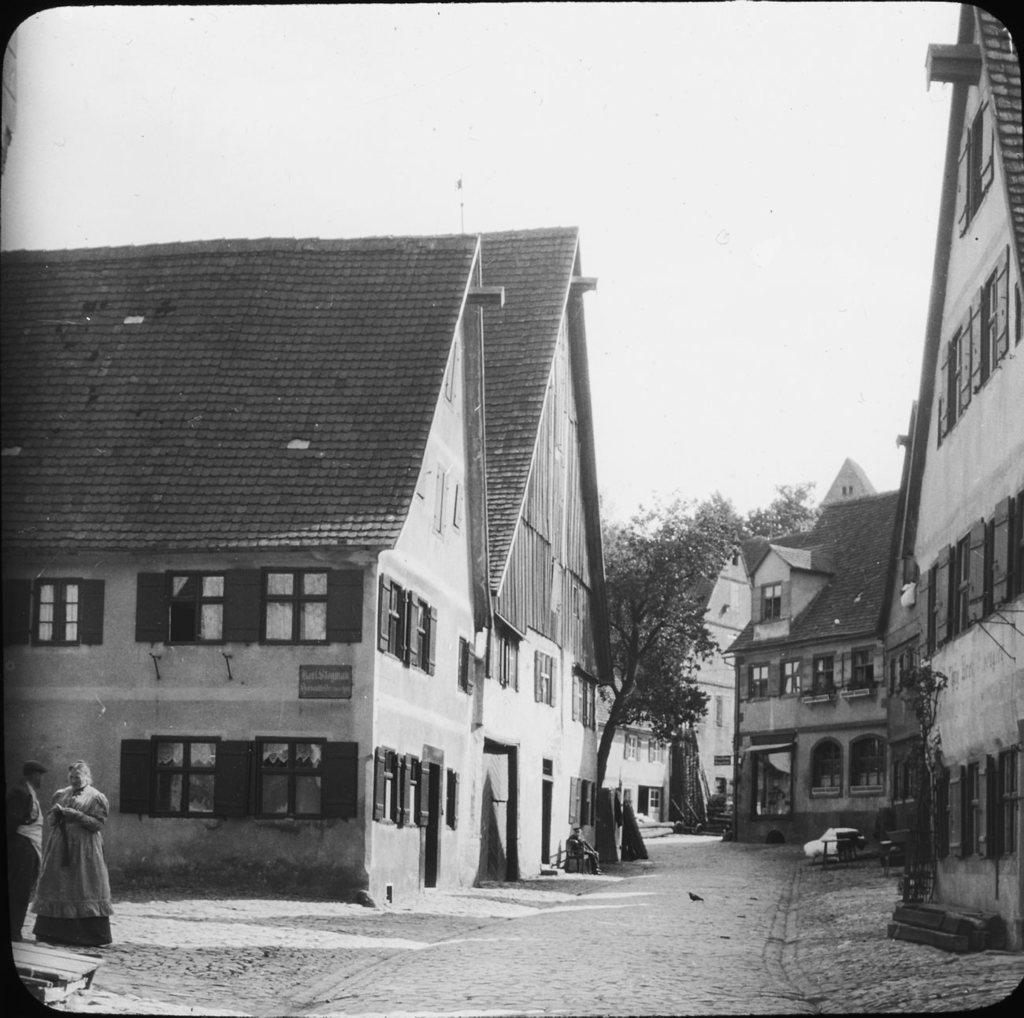Please provide a concise description of this image. This is a black and white picture. In the center of the picture there are houses, trees, windows, doors, road and a person. In the foreground of the picture there are road, soil and people. The picture has a black border. Sky is sunny. 02 